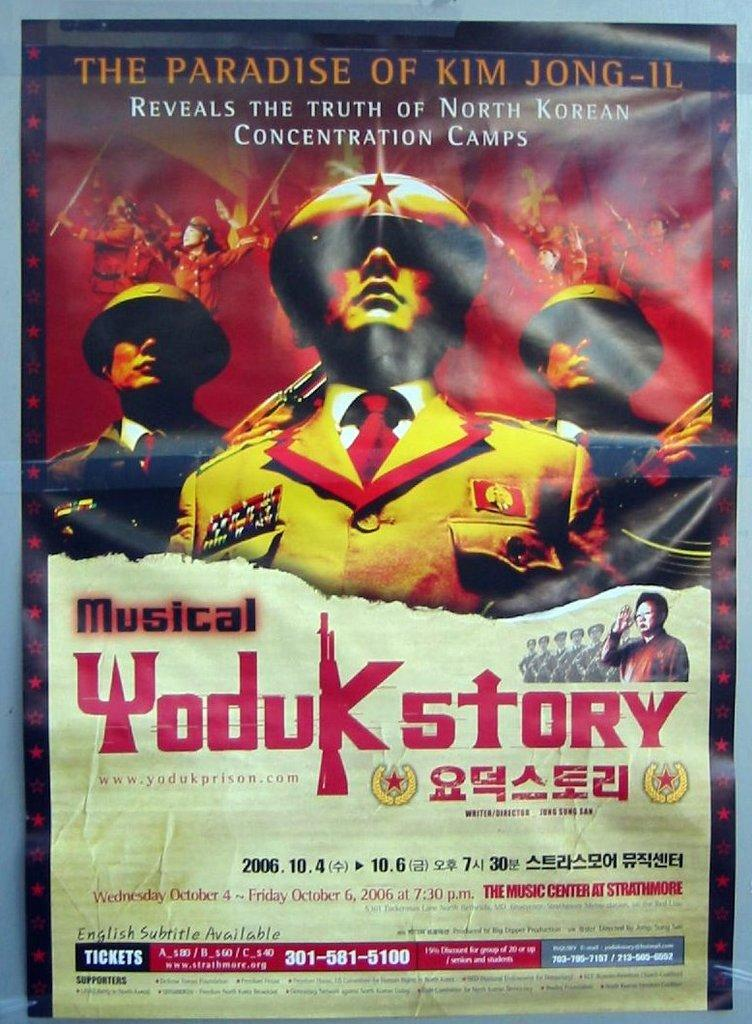<image>
Relay a brief, clear account of the picture shown. A musical about Kim Jong-Il and North Korea's concentration camps. 